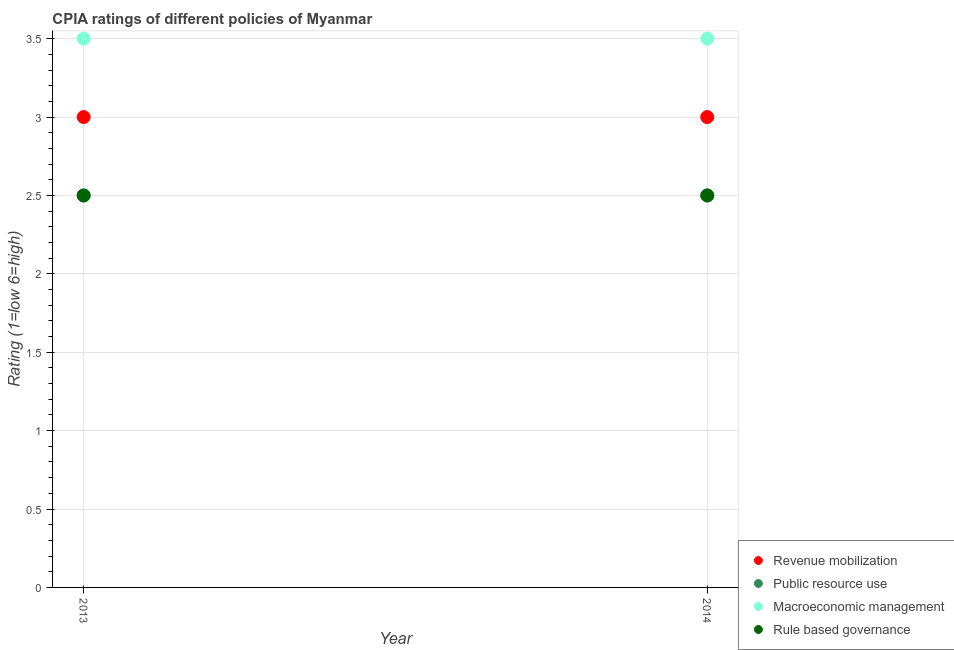Is the number of dotlines equal to the number of legend labels?
Make the answer very short. Yes. Across all years, what is the maximum cpia rating of public resource use?
Your answer should be very brief. 2.5. What is the difference between the cpia rating of rule based governance in 2014 and the cpia rating of macroeconomic management in 2013?
Ensure brevity in your answer.  -1. What is the average cpia rating of revenue mobilization per year?
Your response must be concise. 3. In how many years, is the cpia rating of rule based governance greater than 2.4?
Offer a very short reply. 2. What is the ratio of the cpia rating of revenue mobilization in 2013 to that in 2014?
Provide a short and direct response. 1. Is the cpia rating of rule based governance in 2013 less than that in 2014?
Give a very brief answer. No. Is the cpia rating of macroeconomic management strictly less than the cpia rating of rule based governance over the years?
Give a very brief answer. No. How many dotlines are there?
Provide a succinct answer. 4. Are the values on the major ticks of Y-axis written in scientific E-notation?
Provide a succinct answer. No. Does the graph contain any zero values?
Offer a terse response. No. How are the legend labels stacked?
Keep it short and to the point. Vertical. What is the title of the graph?
Your response must be concise. CPIA ratings of different policies of Myanmar. What is the label or title of the X-axis?
Your answer should be very brief. Year. What is the Rating (1=low 6=high) of Revenue mobilization in 2013?
Provide a short and direct response. 3. What is the Rating (1=low 6=high) of Public resource use in 2014?
Make the answer very short. 2.5. What is the Rating (1=low 6=high) in Rule based governance in 2014?
Keep it short and to the point. 2.5. Across all years, what is the maximum Rating (1=low 6=high) in Public resource use?
Make the answer very short. 2.5. Across all years, what is the minimum Rating (1=low 6=high) of Public resource use?
Give a very brief answer. 2.5. Across all years, what is the minimum Rating (1=low 6=high) of Macroeconomic management?
Keep it short and to the point. 3.5. What is the total Rating (1=low 6=high) in Revenue mobilization in the graph?
Offer a very short reply. 6. What is the total Rating (1=low 6=high) in Public resource use in the graph?
Provide a short and direct response. 5. What is the total Rating (1=low 6=high) in Macroeconomic management in the graph?
Provide a succinct answer. 7. What is the difference between the Rating (1=low 6=high) of Public resource use in 2013 and that in 2014?
Ensure brevity in your answer.  0. What is the difference between the Rating (1=low 6=high) of Revenue mobilization in 2013 and the Rating (1=low 6=high) of Macroeconomic management in 2014?
Offer a terse response. -0.5. What is the average Rating (1=low 6=high) of Macroeconomic management per year?
Your answer should be very brief. 3.5. In the year 2013, what is the difference between the Rating (1=low 6=high) in Revenue mobilization and Rating (1=low 6=high) in Macroeconomic management?
Your response must be concise. -0.5. In the year 2013, what is the difference between the Rating (1=low 6=high) of Public resource use and Rating (1=low 6=high) of Rule based governance?
Make the answer very short. 0. In the year 2013, what is the difference between the Rating (1=low 6=high) in Macroeconomic management and Rating (1=low 6=high) in Rule based governance?
Your answer should be compact. 1. In the year 2014, what is the difference between the Rating (1=low 6=high) of Revenue mobilization and Rating (1=low 6=high) of Public resource use?
Give a very brief answer. 0.5. In the year 2014, what is the difference between the Rating (1=low 6=high) in Revenue mobilization and Rating (1=low 6=high) in Macroeconomic management?
Give a very brief answer. -0.5. In the year 2014, what is the difference between the Rating (1=low 6=high) of Revenue mobilization and Rating (1=low 6=high) of Rule based governance?
Provide a succinct answer. 0.5. In the year 2014, what is the difference between the Rating (1=low 6=high) in Public resource use and Rating (1=low 6=high) in Macroeconomic management?
Keep it short and to the point. -1. In the year 2014, what is the difference between the Rating (1=low 6=high) of Macroeconomic management and Rating (1=low 6=high) of Rule based governance?
Offer a very short reply. 1. What is the ratio of the Rating (1=low 6=high) of Public resource use in 2013 to that in 2014?
Make the answer very short. 1. What is the ratio of the Rating (1=low 6=high) in Macroeconomic management in 2013 to that in 2014?
Keep it short and to the point. 1. What is the difference between the highest and the second highest Rating (1=low 6=high) in Revenue mobilization?
Provide a short and direct response. 0. What is the difference between the highest and the second highest Rating (1=low 6=high) of Public resource use?
Provide a short and direct response. 0. What is the difference between the highest and the second highest Rating (1=low 6=high) in Rule based governance?
Make the answer very short. 0. What is the difference between the highest and the lowest Rating (1=low 6=high) of Revenue mobilization?
Your response must be concise. 0. What is the difference between the highest and the lowest Rating (1=low 6=high) in Public resource use?
Your answer should be very brief. 0. What is the difference between the highest and the lowest Rating (1=low 6=high) of Rule based governance?
Offer a very short reply. 0. 